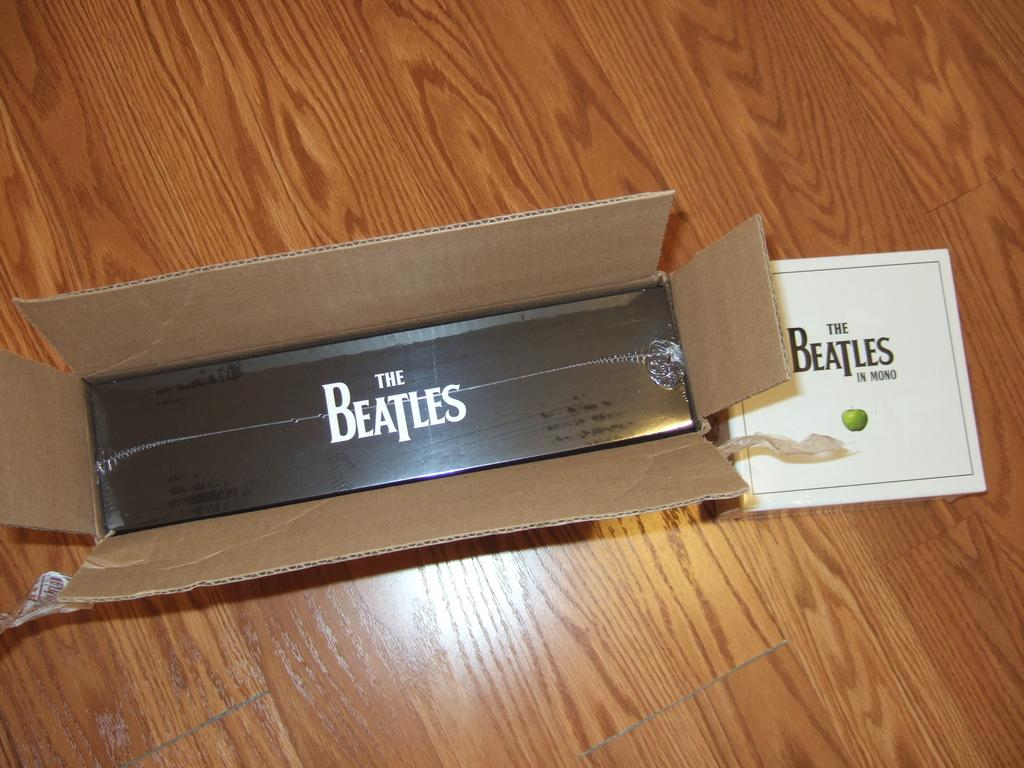<image>
Create a compact narrative representing the image presented. Two boxes both containing musical stuff from the Beatles. 